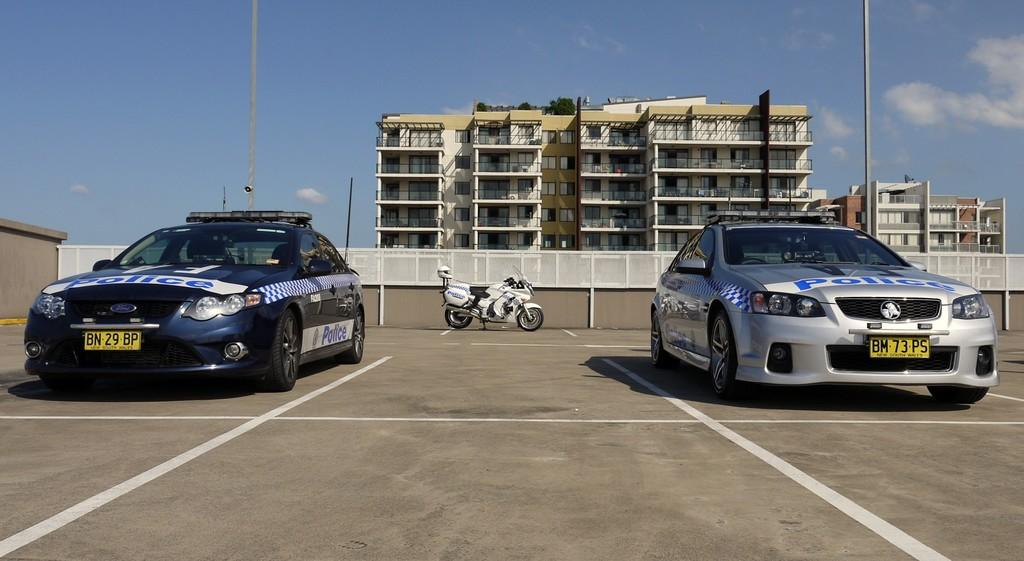What type of vehicles can be seen on the road in the image? There are cars on the road in the image. What other mode of transportation is present on the road? There is a bike on the road in the image. What structures can be seen in the image? There is a fence, poles, and a wall in the image. What security feature is present in the image? There is a security camera in the image. What can be seen in the background of the image? There are buildings, windows, plants, and clouds in the sky in the background of the image. Can you tell me what book the doctor is reading in the image? There is no doctor or book present in the image. What type of support does the fence provide in the image? The image does not provide information about the type of support the fence offers. 